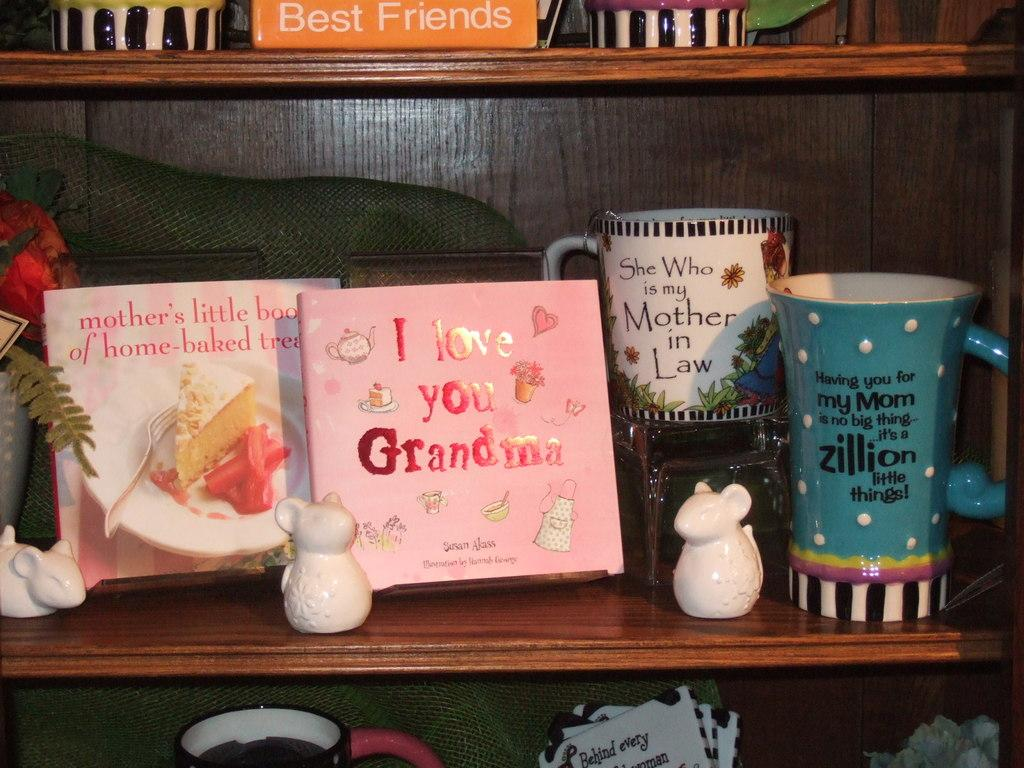What can be seen in the image? There are many decors in the image. Where are the decors located? The decors are arranged in the shelves of a cupboard. What type of doll is present in the image? There is no doll present in the image; it only features decors arranged in the shelves of a cupboard. 